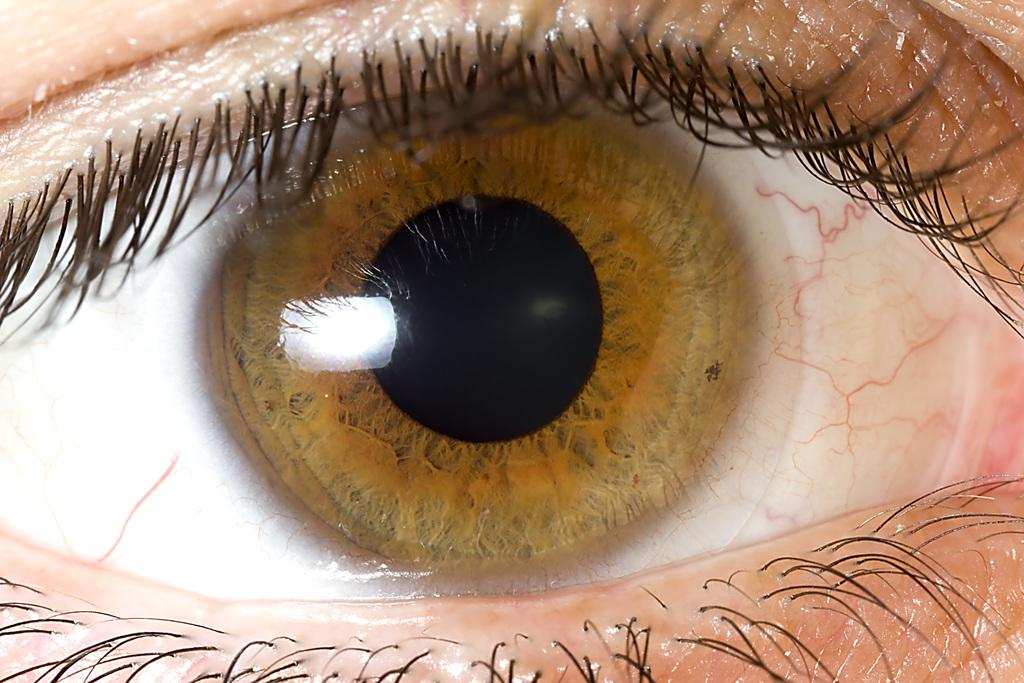What is the main subject of the picture? The main subject of the picture is an eye. What color is the iris of the eye? The iris of the eye has a black color. What color is the sclera of the eye? The sclera of the eye has a white color. What other features can be seen in the eye? Red color nerves are visible in the eye. What is present around the eye? Hair is present around the eye. Can you tell me how many feathers are present around the eye in the image? There are no feathers present around the eye in the image. What type of servant is depicted in the image? There is no servant depicted in the image; it features an eye with specific features and hair around it. 